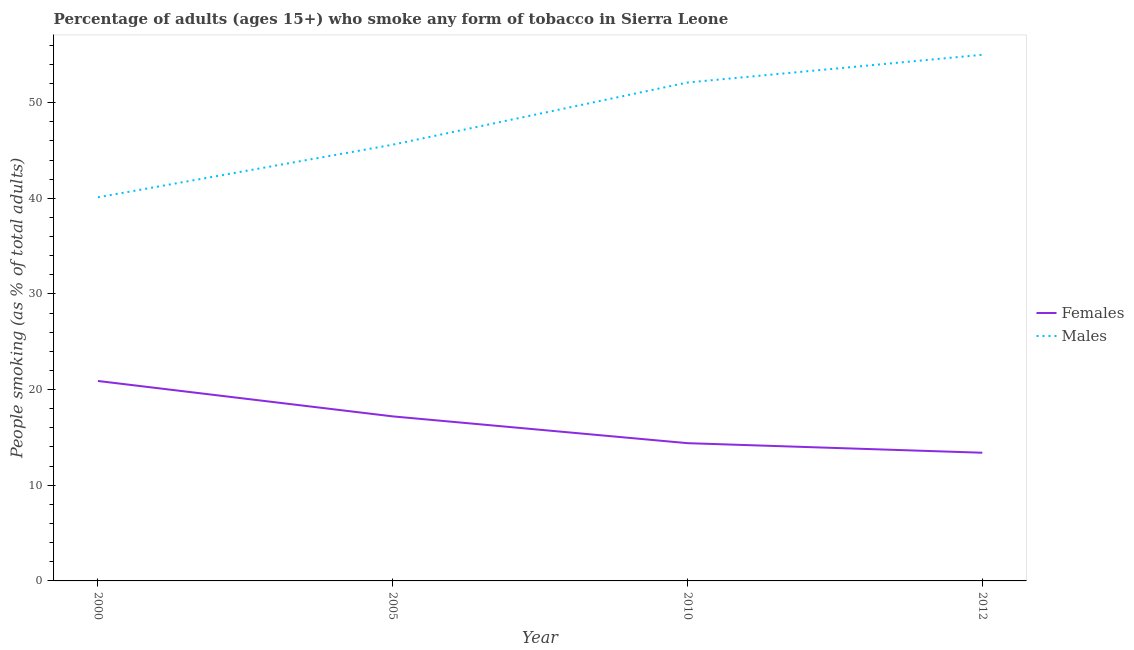How many different coloured lines are there?
Offer a very short reply. 2. Does the line corresponding to percentage of females who smoke intersect with the line corresponding to percentage of males who smoke?
Your answer should be compact. No. Across all years, what is the maximum percentage of females who smoke?
Your answer should be compact. 20.9. Across all years, what is the minimum percentage of females who smoke?
Offer a terse response. 13.4. In which year was the percentage of females who smoke maximum?
Offer a terse response. 2000. In which year was the percentage of males who smoke minimum?
Your answer should be very brief. 2000. What is the total percentage of males who smoke in the graph?
Ensure brevity in your answer.  192.8. What is the difference between the percentage of males who smoke in 2000 and that in 2012?
Your answer should be very brief. -14.9. What is the difference between the percentage of females who smoke in 2005 and the percentage of males who smoke in 2012?
Provide a short and direct response. -37.8. What is the average percentage of females who smoke per year?
Ensure brevity in your answer.  16.47. In the year 2012, what is the difference between the percentage of females who smoke and percentage of males who smoke?
Provide a succinct answer. -41.6. In how many years, is the percentage of females who smoke greater than 2 %?
Give a very brief answer. 4. What is the ratio of the percentage of females who smoke in 2005 to that in 2010?
Offer a terse response. 1.19. Is the percentage of males who smoke in 2000 less than that in 2012?
Ensure brevity in your answer.  Yes. What is the difference between the highest and the second highest percentage of males who smoke?
Offer a terse response. 2.9. What is the difference between the highest and the lowest percentage of males who smoke?
Your response must be concise. 14.9. Does the percentage of females who smoke monotonically increase over the years?
Your answer should be very brief. No. Is the percentage of males who smoke strictly less than the percentage of females who smoke over the years?
Keep it short and to the point. No. How many lines are there?
Make the answer very short. 2. How many years are there in the graph?
Offer a terse response. 4. What is the difference between two consecutive major ticks on the Y-axis?
Ensure brevity in your answer.  10. Does the graph contain grids?
Give a very brief answer. No. How are the legend labels stacked?
Ensure brevity in your answer.  Vertical. What is the title of the graph?
Ensure brevity in your answer.  Percentage of adults (ages 15+) who smoke any form of tobacco in Sierra Leone. What is the label or title of the X-axis?
Your response must be concise. Year. What is the label or title of the Y-axis?
Give a very brief answer. People smoking (as % of total adults). What is the People smoking (as % of total adults) in Females in 2000?
Your answer should be compact. 20.9. What is the People smoking (as % of total adults) of Males in 2000?
Your answer should be compact. 40.1. What is the People smoking (as % of total adults) of Females in 2005?
Provide a short and direct response. 17.2. What is the People smoking (as % of total adults) in Males in 2005?
Your response must be concise. 45.6. What is the People smoking (as % of total adults) in Males in 2010?
Provide a succinct answer. 52.1. What is the People smoking (as % of total adults) in Females in 2012?
Make the answer very short. 13.4. Across all years, what is the maximum People smoking (as % of total adults) in Females?
Your response must be concise. 20.9. Across all years, what is the minimum People smoking (as % of total adults) in Males?
Provide a succinct answer. 40.1. What is the total People smoking (as % of total adults) of Females in the graph?
Keep it short and to the point. 65.9. What is the total People smoking (as % of total adults) of Males in the graph?
Your response must be concise. 192.8. What is the difference between the People smoking (as % of total adults) in Females in 2000 and that in 2005?
Your answer should be very brief. 3.7. What is the difference between the People smoking (as % of total adults) in Males in 2000 and that in 2010?
Give a very brief answer. -12. What is the difference between the People smoking (as % of total adults) of Females in 2000 and that in 2012?
Keep it short and to the point. 7.5. What is the difference between the People smoking (as % of total adults) in Males in 2000 and that in 2012?
Offer a very short reply. -14.9. What is the difference between the People smoking (as % of total adults) in Females in 2005 and that in 2010?
Your answer should be very brief. 2.8. What is the difference between the People smoking (as % of total adults) in Males in 2005 and that in 2010?
Your answer should be compact. -6.5. What is the difference between the People smoking (as % of total adults) in Females in 2005 and that in 2012?
Your answer should be compact. 3.8. What is the difference between the People smoking (as % of total adults) of Females in 2010 and that in 2012?
Offer a very short reply. 1. What is the difference between the People smoking (as % of total adults) of Males in 2010 and that in 2012?
Provide a short and direct response. -2.9. What is the difference between the People smoking (as % of total adults) in Females in 2000 and the People smoking (as % of total adults) in Males in 2005?
Your response must be concise. -24.7. What is the difference between the People smoking (as % of total adults) of Females in 2000 and the People smoking (as % of total adults) of Males in 2010?
Provide a short and direct response. -31.2. What is the difference between the People smoking (as % of total adults) of Females in 2000 and the People smoking (as % of total adults) of Males in 2012?
Offer a terse response. -34.1. What is the difference between the People smoking (as % of total adults) in Females in 2005 and the People smoking (as % of total adults) in Males in 2010?
Your response must be concise. -34.9. What is the difference between the People smoking (as % of total adults) in Females in 2005 and the People smoking (as % of total adults) in Males in 2012?
Offer a very short reply. -37.8. What is the difference between the People smoking (as % of total adults) of Females in 2010 and the People smoking (as % of total adults) of Males in 2012?
Make the answer very short. -40.6. What is the average People smoking (as % of total adults) of Females per year?
Provide a succinct answer. 16.48. What is the average People smoking (as % of total adults) of Males per year?
Give a very brief answer. 48.2. In the year 2000, what is the difference between the People smoking (as % of total adults) in Females and People smoking (as % of total adults) in Males?
Offer a terse response. -19.2. In the year 2005, what is the difference between the People smoking (as % of total adults) of Females and People smoking (as % of total adults) of Males?
Make the answer very short. -28.4. In the year 2010, what is the difference between the People smoking (as % of total adults) of Females and People smoking (as % of total adults) of Males?
Your answer should be very brief. -37.7. In the year 2012, what is the difference between the People smoking (as % of total adults) in Females and People smoking (as % of total adults) in Males?
Offer a terse response. -41.6. What is the ratio of the People smoking (as % of total adults) in Females in 2000 to that in 2005?
Provide a succinct answer. 1.22. What is the ratio of the People smoking (as % of total adults) of Males in 2000 to that in 2005?
Offer a terse response. 0.88. What is the ratio of the People smoking (as % of total adults) in Females in 2000 to that in 2010?
Your answer should be compact. 1.45. What is the ratio of the People smoking (as % of total adults) of Males in 2000 to that in 2010?
Provide a short and direct response. 0.77. What is the ratio of the People smoking (as % of total adults) of Females in 2000 to that in 2012?
Ensure brevity in your answer.  1.56. What is the ratio of the People smoking (as % of total adults) of Males in 2000 to that in 2012?
Provide a succinct answer. 0.73. What is the ratio of the People smoking (as % of total adults) of Females in 2005 to that in 2010?
Offer a terse response. 1.19. What is the ratio of the People smoking (as % of total adults) of Males in 2005 to that in 2010?
Your answer should be compact. 0.88. What is the ratio of the People smoking (as % of total adults) of Females in 2005 to that in 2012?
Ensure brevity in your answer.  1.28. What is the ratio of the People smoking (as % of total adults) of Males in 2005 to that in 2012?
Provide a short and direct response. 0.83. What is the ratio of the People smoking (as % of total adults) in Females in 2010 to that in 2012?
Offer a very short reply. 1.07. What is the ratio of the People smoking (as % of total adults) in Males in 2010 to that in 2012?
Make the answer very short. 0.95. What is the difference between the highest and the second highest People smoking (as % of total adults) of Females?
Make the answer very short. 3.7. What is the difference between the highest and the second highest People smoking (as % of total adults) of Males?
Keep it short and to the point. 2.9. What is the difference between the highest and the lowest People smoking (as % of total adults) in Males?
Offer a terse response. 14.9. 